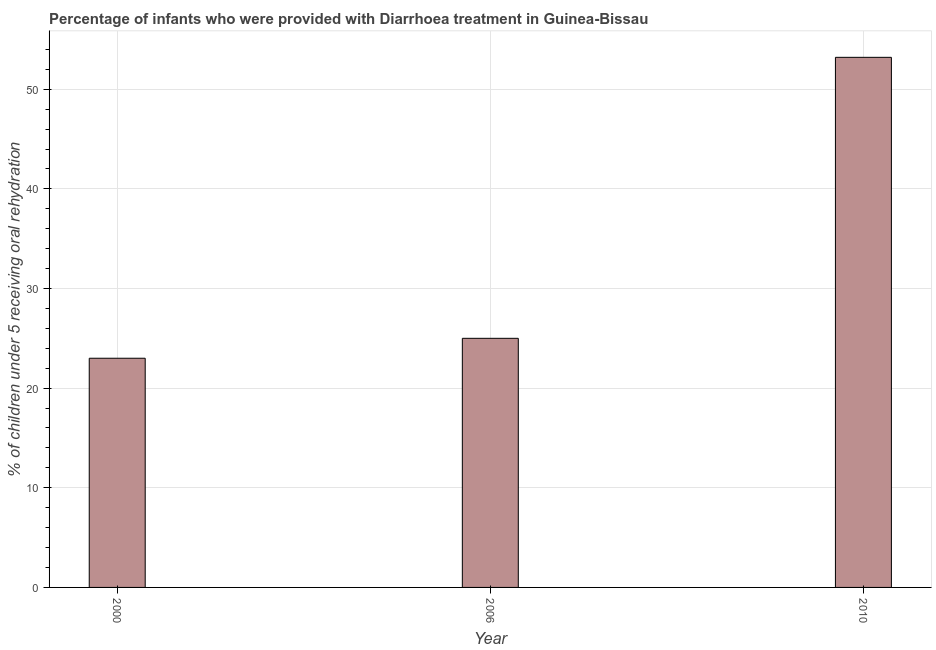Does the graph contain any zero values?
Make the answer very short. No. What is the title of the graph?
Your answer should be compact. Percentage of infants who were provided with Diarrhoea treatment in Guinea-Bissau. What is the label or title of the Y-axis?
Your response must be concise. % of children under 5 receiving oral rehydration. What is the percentage of children who were provided with treatment diarrhoea in 2006?
Give a very brief answer. 25. Across all years, what is the maximum percentage of children who were provided with treatment diarrhoea?
Keep it short and to the point. 53.2. In which year was the percentage of children who were provided with treatment diarrhoea maximum?
Keep it short and to the point. 2010. In which year was the percentage of children who were provided with treatment diarrhoea minimum?
Keep it short and to the point. 2000. What is the sum of the percentage of children who were provided with treatment diarrhoea?
Your answer should be compact. 101.2. What is the difference between the percentage of children who were provided with treatment diarrhoea in 2000 and 2010?
Your answer should be compact. -30.2. What is the average percentage of children who were provided with treatment diarrhoea per year?
Offer a very short reply. 33.73. What is the median percentage of children who were provided with treatment diarrhoea?
Provide a short and direct response. 25. In how many years, is the percentage of children who were provided with treatment diarrhoea greater than 38 %?
Offer a terse response. 1. Is the percentage of children who were provided with treatment diarrhoea in 2006 less than that in 2010?
Provide a succinct answer. Yes. Is the difference between the percentage of children who were provided with treatment diarrhoea in 2006 and 2010 greater than the difference between any two years?
Keep it short and to the point. No. What is the difference between the highest and the second highest percentage of children who were provided with treatment diarrhoea?
Give a very brief answer. 28.2. Is the sum of the percentage of children who were provided with treatment diarrhoea in 2000 and 2010 greater than the maximum percentage of children who were provided with treatment diarrhoea across all years?
Give a very brief answer. Yes. What is the difference between the highest and the lowest percentage of children who were provided with treatment diarrhoea?
Offer a terse response. 30.2. In how many years, is the percentage of children who were provided with treatment diarrhoea greater than the average percentage of children who were provided with treatment diarrhoea taken over all years?
Make the answer very short. 1. How many bars are there?
Your response must be concise. 3. Are all the bars in the graph horizontal?
Offer a terse response. No. What is the difference between two consecutive major ticks on the Y-axis?
Provide a succinct answer. 10. What is the % of children under 5 receiving oral rehydration of 2006?
Make the answer very short. 25. What is the % of children under 5 receiving oral rehydration in 2010?
Provide a succinct answer. 53.2. What is the difference between the % of children under 5 receiving oral rehydration in 2000 and 2010?
Offer a very short reply. -30.2. What is the difference between the % of children under 5 receiving oral rehydration in 2006 and 2010?
Keep it short and to the point. -28.2. What is the ratio of the % of children under 5 receiving oral rehydration in 2000 to that in 2010?
Make the answer very short. 0.43. What is the ratio of the % of children under 5 receiving oral rehydration in 2006 to that in 2010?
Offer a terse response. 0.47. 